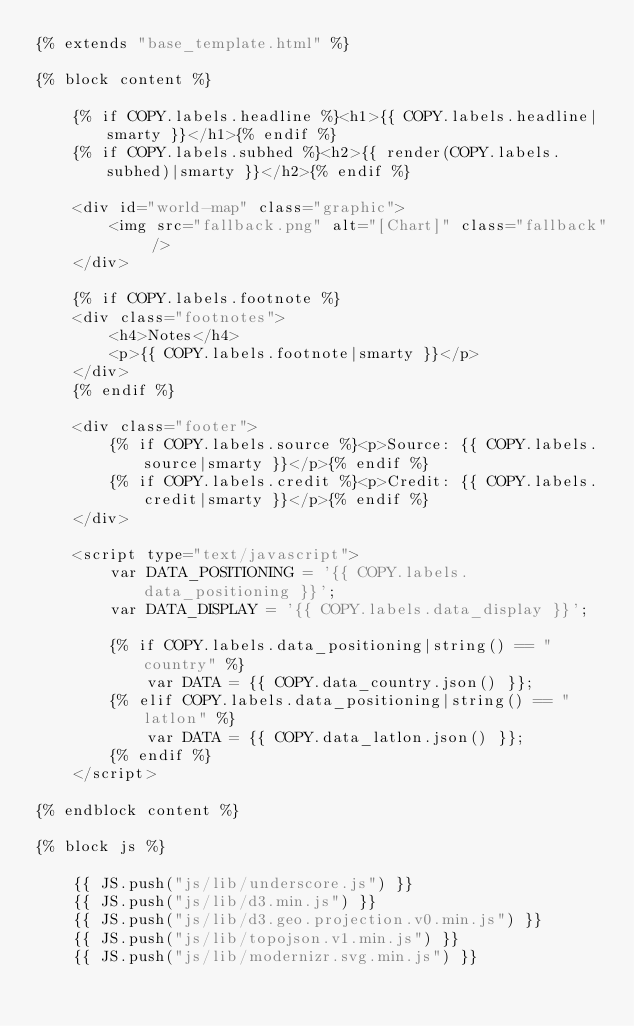Convert code to text. <code><loc_0><loc_0><loc_500><loc_500><_HTML_>{% extends "base_template.html" %}

{% block content %}

    {% if COPY.labels.headline %}<h1>{{ COPY.labels.headline|smarty }}</h1>{% endif %}
    {% if COPY.labels.subhed %}<h2>{{ render(COPY.labels.subhed)|smarty }}</h2>{% endif %}

    <div id="world-map" class="graphic">
        <img src="fallback.png" alt="[Chart]" class="fallback" />
    </div>

    {% if COPY.labels.footnote %}
    <div class="footnotes">
        <h4>Notes</h4>
        <p>{{ COPY.labels.footnote|smarty }}</p>
    </div>
    {% endif %}

    <div class="footer">
        {% if COPY.labels.source %}<p>Source: {{ COPY.labels.source|smarty }}</p>{% endif %}
        {% if COPY.labels.credit %}<p>Credit: {{ COPY.labels.credit|smarty }}</p>{% endif %}
    </div>

    <script type="text/javascript">
        var DATA_POSITIONING = '{{ COPY.labels.data_positioning }}';
        var DATA_DISPLAY = '{{ COPY.labels.data_display }}';

        {% if COPY.labels.data_positioning|string() == "country" %}
            var DATA = {{ COPY.data_country.json() }};
        {% elif COPY.labels.data_positioning|string() == "latlon" %}
            var DATA = {{ COPY.data_latlon.json() }};
        {% endif %}
    </script>

{% endblock content %}

{% block js %}

    {{ JS.push("js/lib/underscore.js") }}
    {{ JS.push("js/lib/d3.min.js") }}
    {{ JS.push("js/lib/d3.geo.projection.v0.min.js") }}
    {{ JS.push("js/lib/topojson.v1.min.js") }}
    {{ JS.push("js/lib/modernizr.svg.min.js") }}</code> 